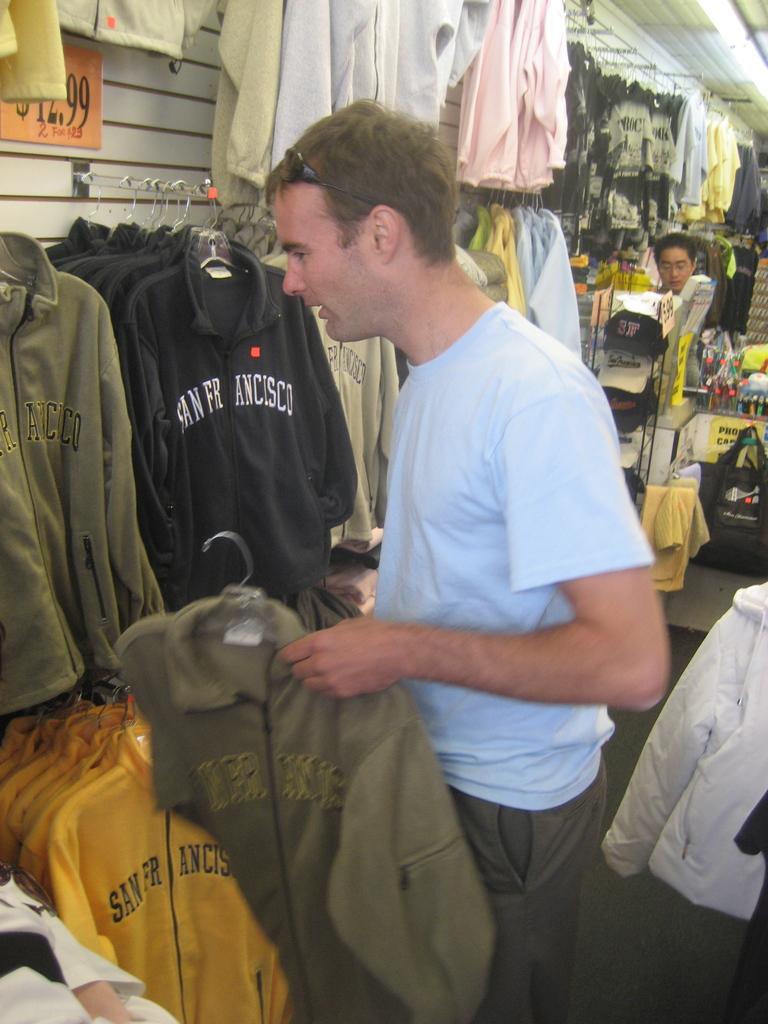What city is mentioned on the black hoodie?
Your answer should be very brief. San francisco. What city is on the brown shirt?
Provide a short and direct response. San francisco. 